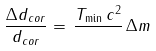Convert formula to latex. <formula><loc_0><loc_0><loc_500><loc_500>\frac { \Delta d _ { c o r } } { d _ { c o r } } = \, \frac { T _ { \min } \, c ^ { 2 } } { } \, \Delta m</formula> 